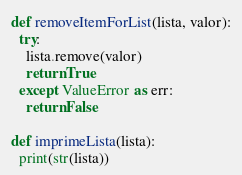<code> <loc_0><loc_0><loc_500><loc_500><_Python_>
def removeItemForList(lista, valor):
  try:
    lista.remove(valor)
    return True
  except ValueError as err:
    return False

def imprimeLista(lista):
  print(str(lista))</code> 